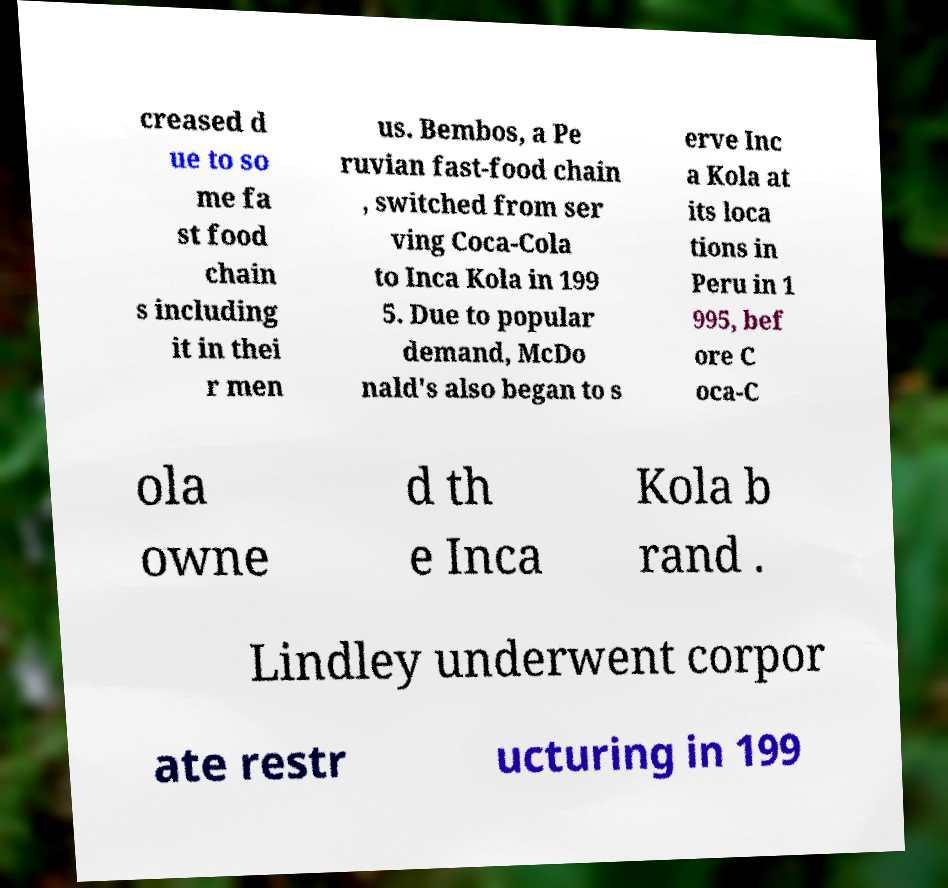Please identify and transcribe the text found in this image. creased d ue to so me fa st food chain s including it in thei r men us. Bembos, a Pe ruvian fast-food chain , switched from ser ving Coca-Cola to Inca Kola in 199 5. Due to popular demand, McDo nald's also began to s erve Inc a Kola at its loca tions in Peru in 1 995, bef ore C oca-C ola owne d th e Inca Kola b rand . Lindley underwent corpor ate restr ucturing in 199 